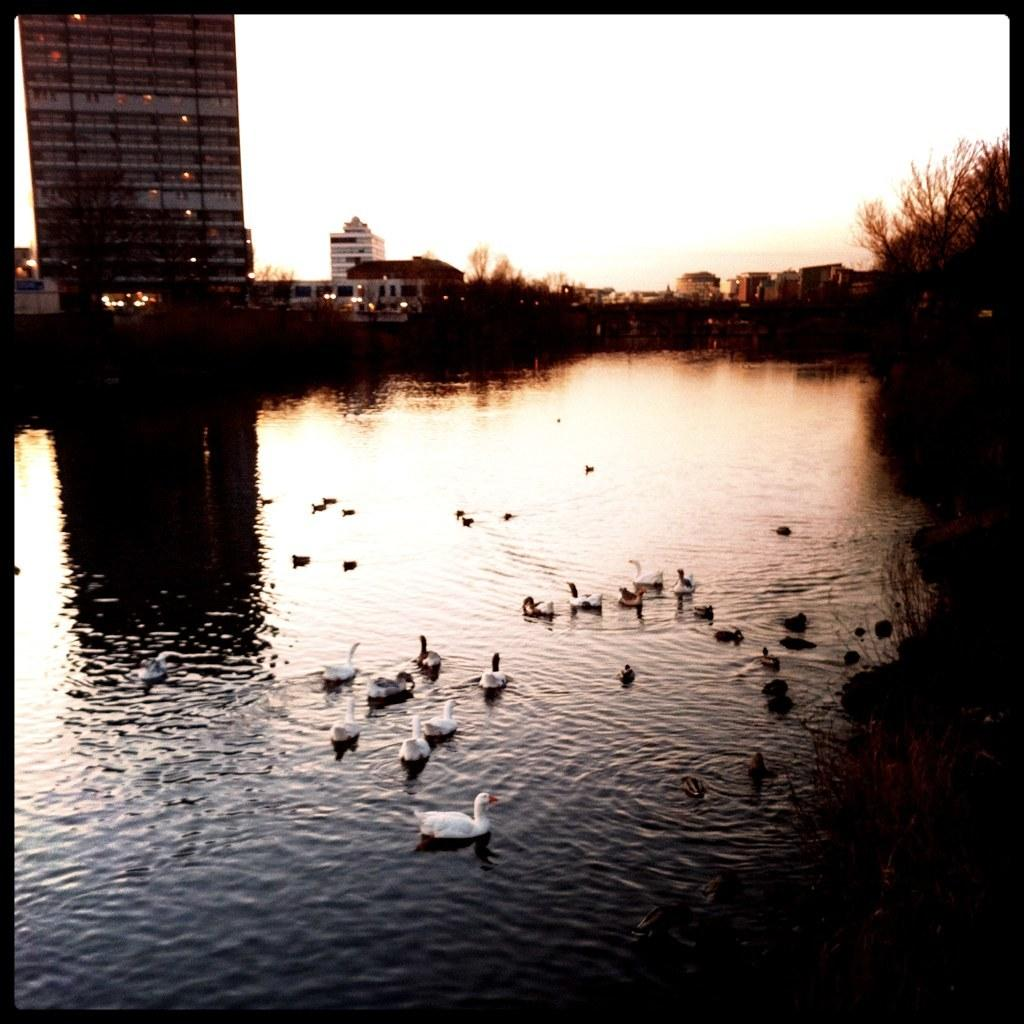What animals can be seen in the image? There is a group of birds in the image. Where are the birds located? The birds are on the water. What type of vegetation is present in the image? There are trees in the image. What type of structures can be seen in the image? There are buildings in the image. What type of illumination is present in the image? There are lights in the image. What can be seen in the background of the image? The sky is visible in the background of the image. What invention is being demonstrated by the birds in the image? There is no invention being demonstrated by the birds in the image; they are simply birds on the water. What type of neck accessory is being worn by the birds in the image? There are no neck accessories present on the birds in the image. 